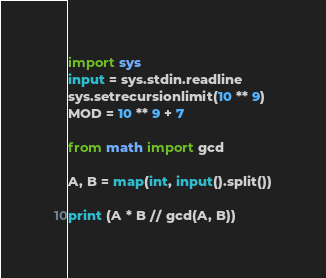<code> <loc_0><loc_0><loc_500><loc_500><_Python_>import sys
input = sys.stdin.readline
sys.setrecursionlimit(10 ** 9)
MOD = 10 ** 9 + 7

from math import gcd

A, B = map(int, input().split())

print (A * B // gcd(A, B))</code> 